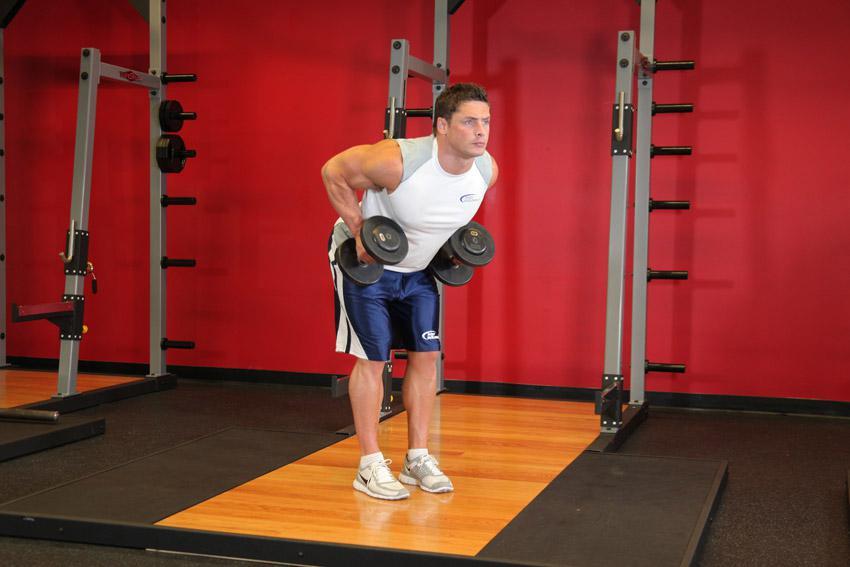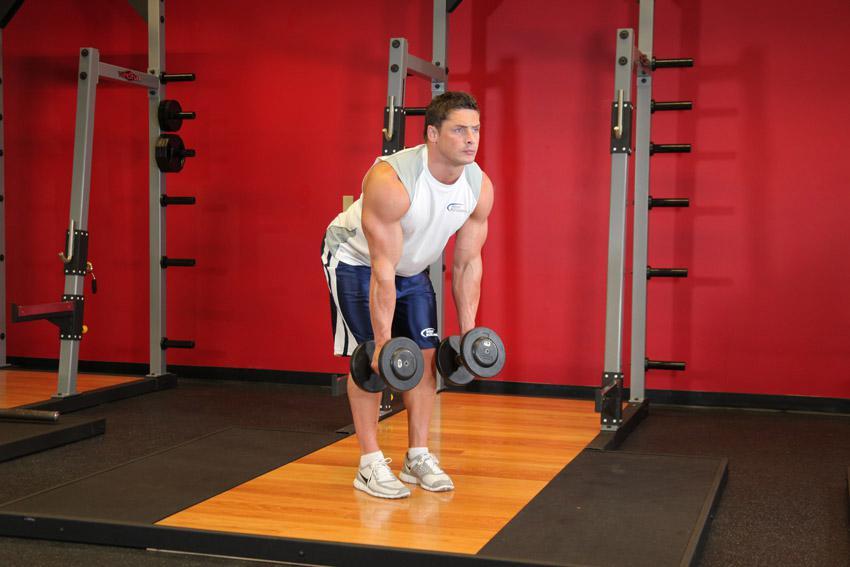The first image is the image on the left, the second image is the image on the right. Assess this claim about the two images: "There are at least two humans in the left image.". Correct or not? Answer yes or no. No. The first image is the image on the left, the second image is the image on the right. Analyze the images presented: Is the assertion "Each image includes the same number of people, and each person is demonstrating the same type of workout and wearing the same attire." valid? Answer yes or no. Yes. 